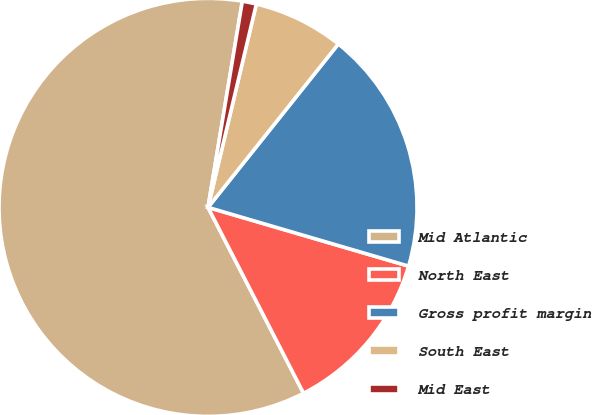Convert chart to OTSL. <chart><loc_0><loc_0><loc_500><loc_500><pie_chart><fcel>Mid Atlantic<fcel>North East<fcel>Gross profit margin<fcel>South East<fcel>Mid East<nl><fcel>60.18%<fcel>12.91%<fcel>18.82%<fcel>7.0%<fcel>1.09%<nl></chart> 